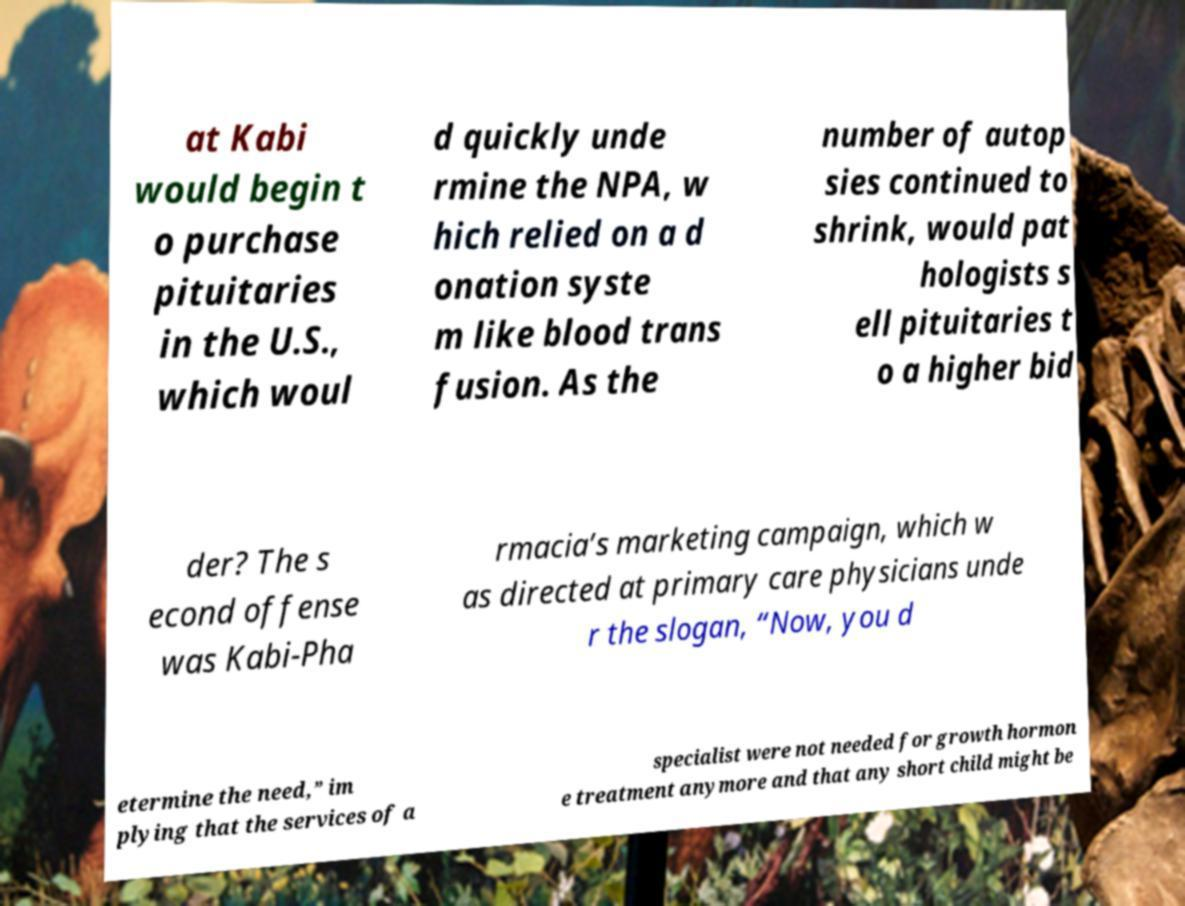Can you accurately transcribe the text from the provided image for me? at Kabi would begin t o purchase pituitaries in the U.S., which woul d quickly unde rmine the NPA, w hich relied on a d onation syste m like blood trans fusion. As the number of autop sies continued to shrink, would pat hologists s ell pituitaries t o a higher bid der? The s econd offense was Kabi-Pha rmacia’s marketing campaign, which w as directed at primary care physicians unde r the slogan, “Now, you d etermine the need,” im plying that the services of a specialist were not needed for growth hormon e treatment anymore and that any short child might be 